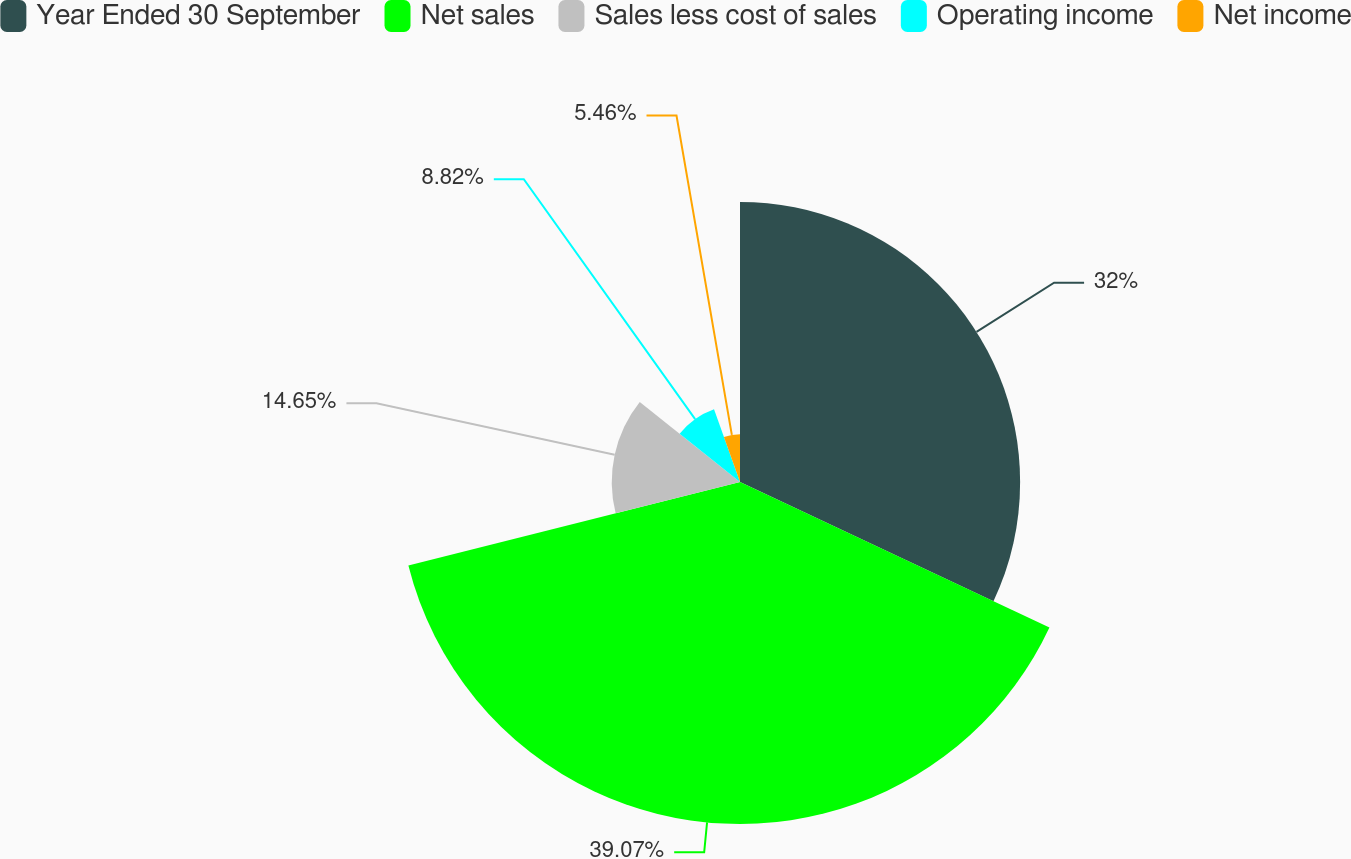<chart> <loc_0><loc_0><loc_500><loc_500><pie_chart><fcel>Year Ended 30 September<fcel>Net sales<fcel>Sales less cost of sales<fcel>Operating income<fcel>Net income<nl><fcel>32.0%<fcel>39.07%<fcel>14.65%<fcel>8.82%<fcel>5.46%<nl></chart> 